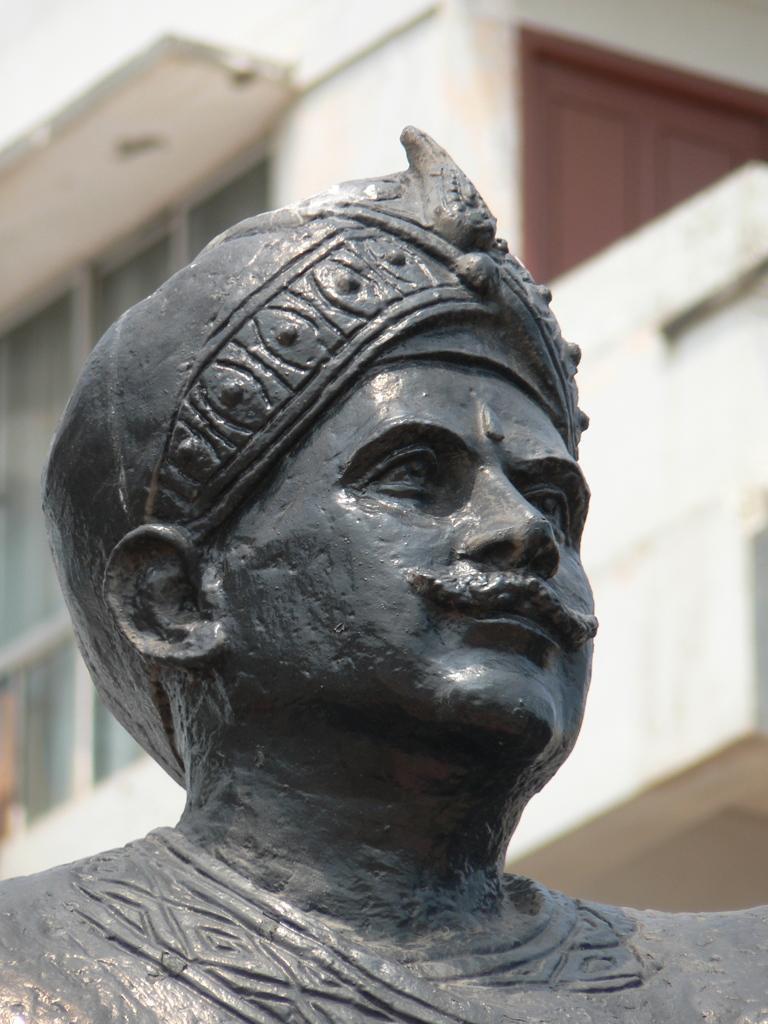Please provide a concise description of this image. In the foreground I can see a person's statue. In the background I can see a building. This image is taken during a day. 